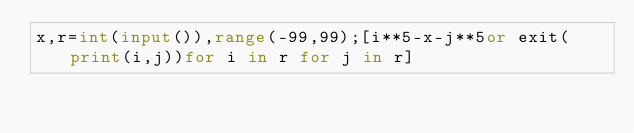<code> <loc_0><loc_0><loc_500><loc_500><_Python_>x,r=int(input()),range(-99,99);[i**5-x-j**5or exit(print(i,j))for i in r for j in r]</code> 